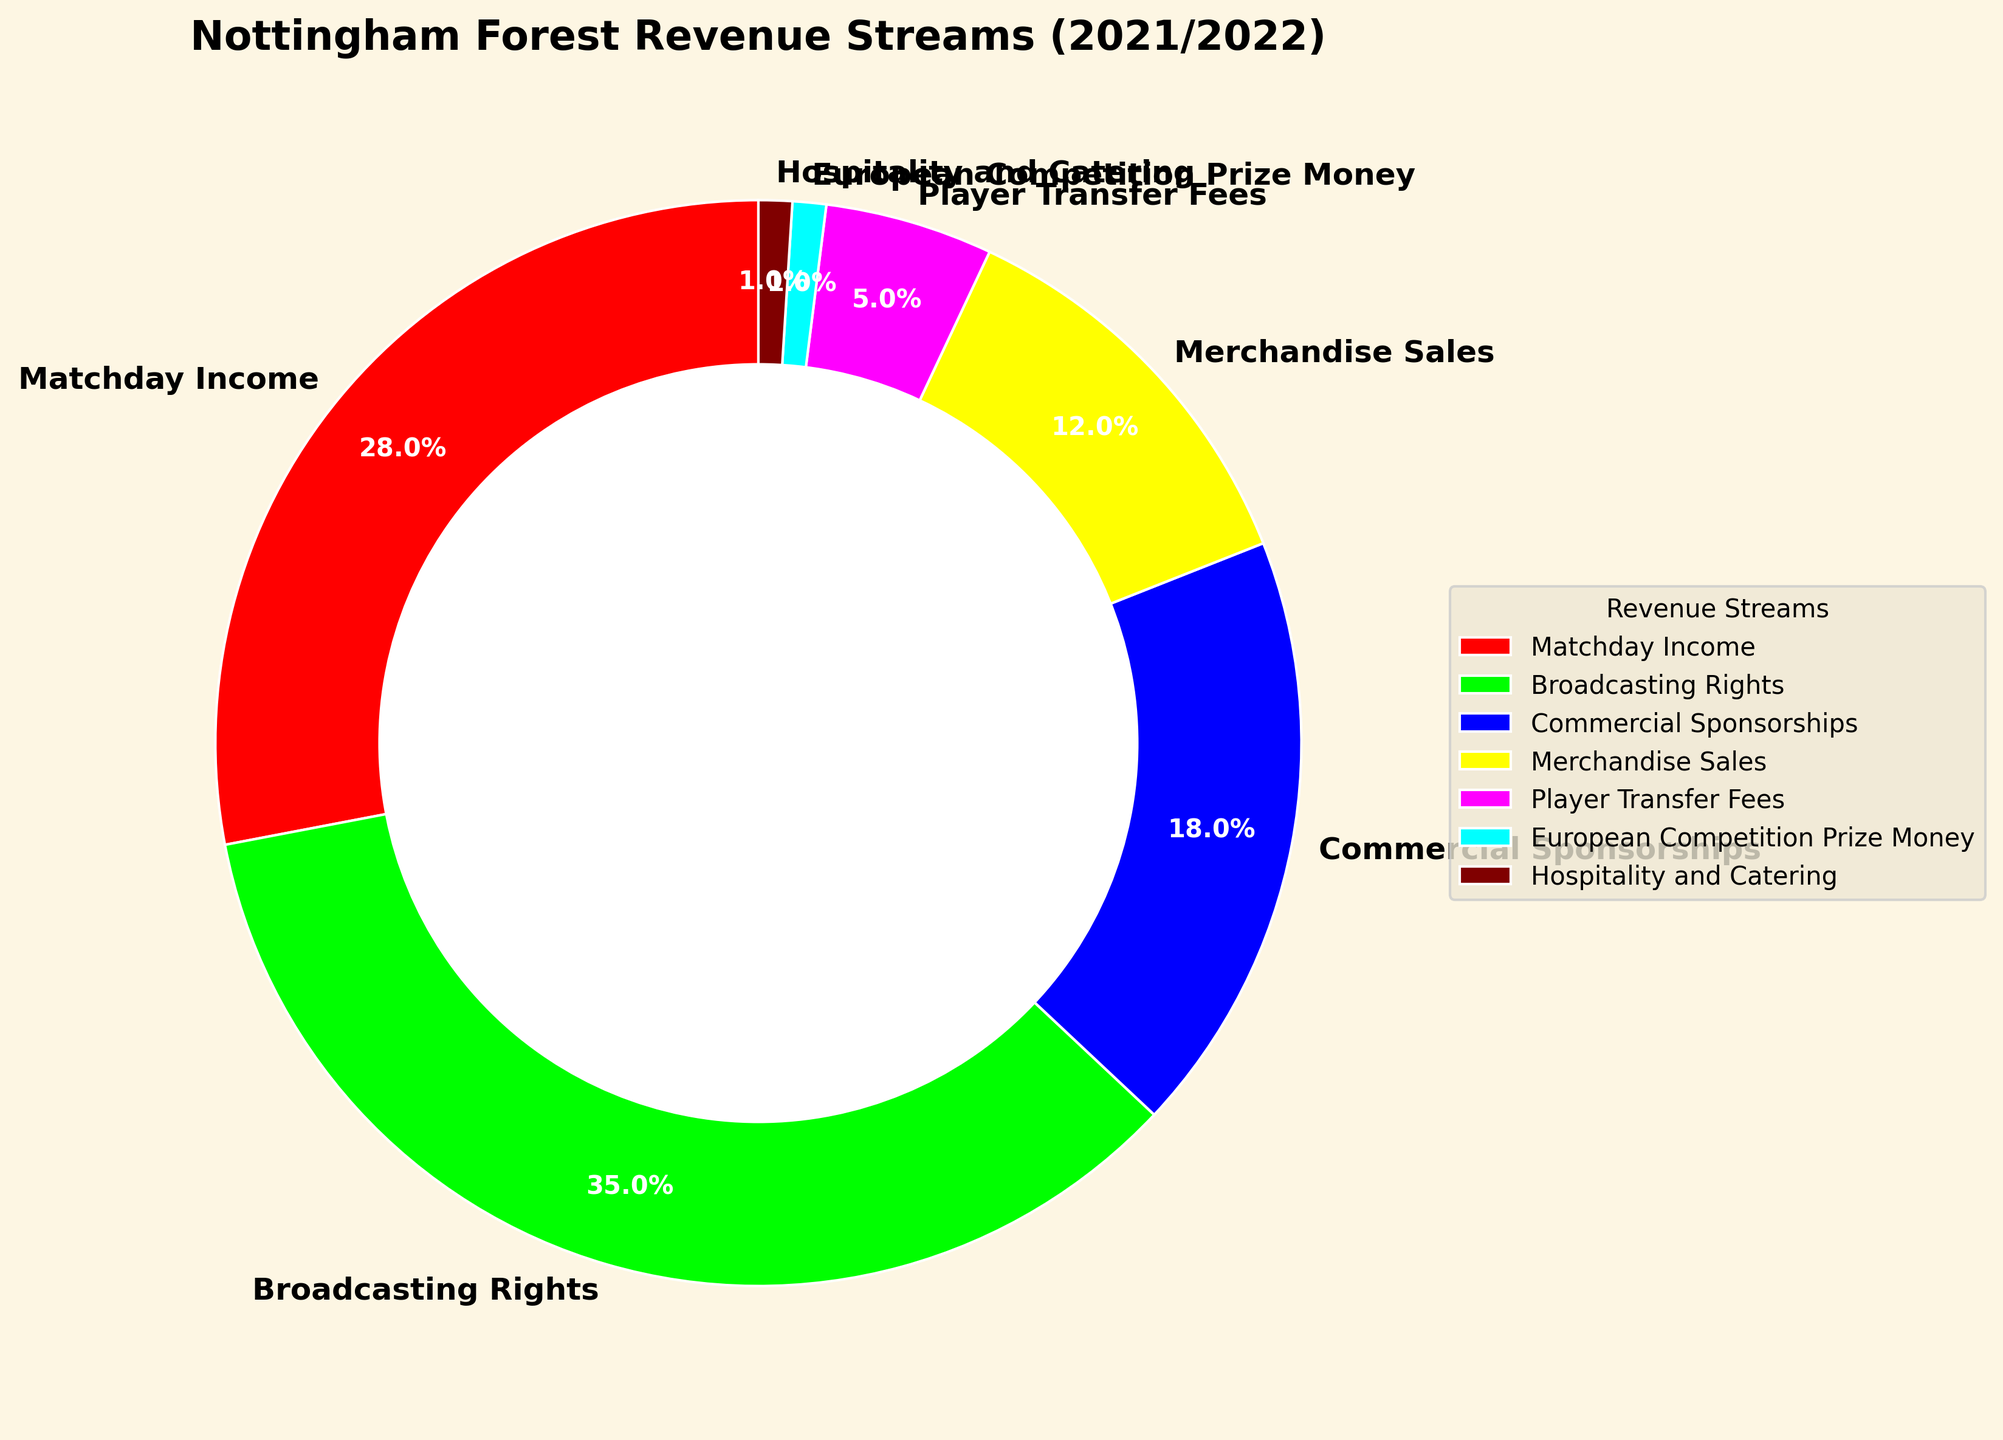What's the largest revenue stream for Nottingham Forest in the 2021/2022 season? The figure shows different revenue streams as segments of the pie chart. The largest segment corresponds to Broadcasting Rights, which is 35%.
Answer: Broadcasting Rights What percentage of revenue comes from Matchday Income and Commercial Sponsorships combined? Matchday Income is 28% and Commercial Sponsorships is 18%. Adding them together: 28% + 18% = 46%.
Answer: 46% Which revenue stream contributes the least to Nottingham Forest's revenue in the 2021/2022 season? The smallest segments in the pie chart are European Competition Prize Money and Hospitality and Catering, both at 1%.
Answer: European Competition Prize Money and Hospitality and Catering How much more does Broadcasting Rights contribute compared to Merchandise Sales? Broadcasting Rights is 35% and Merchandise Sales is 12%. Subtract Merchandise Sales from Broadcasting Rights: 35% - 12% = 23%.
Answer: 23% How does the contribution of Player Transfer Fees compare to Matchday Income? Player Transfer Fees account for 5% while Matchday Income is 28%. Player Transfer Fees contribute less than Matchday Income.
Answer: Less than Which revenue streams are represented by the color red and yellow? By examining the pie chart, the color red represents Matchday Income, and the color yellow represents Merchandise Sales.
Answer: Matchday Income and Merchandise Sales If you combine the revenue from Player Transfer Fees and European Competition Prize Money, what percentage of total revenue does that represent? Player Transfer Fees contribute 5% and European Competition Prize Money is 1%. Adding them together: 5% + 1% = 6%.
Answer: 6% What is the difference in percentage between the revenue from Broadcasting Rights and Commercial Sponsorships? Broadcasting Rights is 35% and Commercial Sponsorships is 18%. Subtract Commercial Sponsorships from Broadcasting Rights: 35% - 18% = 17%.
Answer: 17% Which revenue streams contribute to less than 10% of Nottingham Forest's total revenue? The segments less than 10% are Player Transfer Fees (5%), European Competition Prize Money (1%), and Hospitality and Catering (1%).
Answer: Player Transfer Fees, European Competition Prize Money, and Hospitality and Catering 